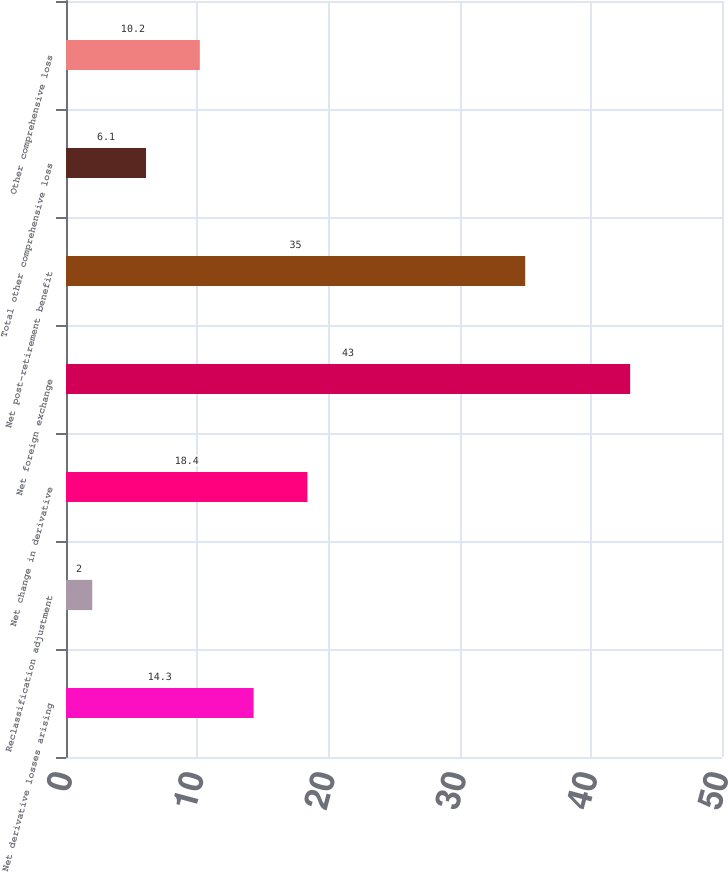<chart> <loc_0><loc_0><loc_500><loc_500><bar_chart><fcel>Net derivative losses arising<fcel>Reclassification adjustment<fcel>Net change in derivative<fcel>Net foreign exchange<fcel>Net post-retirement benefit<fcel>Total other comprehensive loss<fcel>Other comprehensive loss<nl><fcel>14.3<fcel>2<fcel>18.4<fcel>43<fcel>35<fcel>6.1<fcel>10.2<nl></chart> 